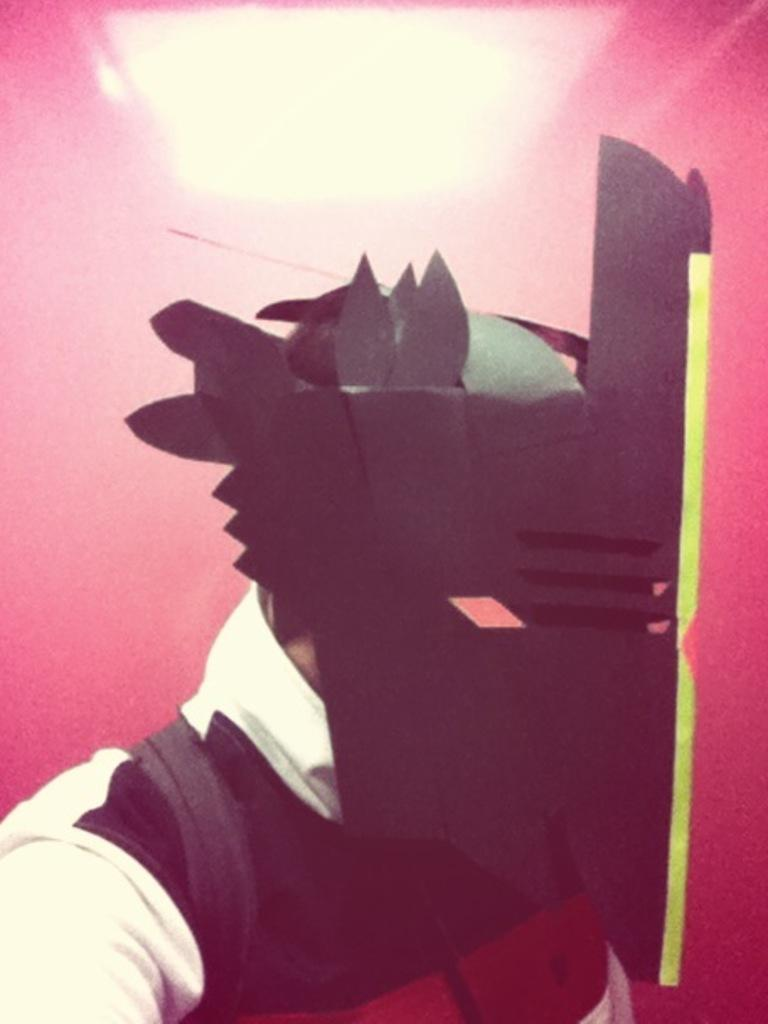Who or what is the main subject of the image? There is a person in the image. What is the person wearing on their face? The person is wearing a mask. What color is the background of the image? The background of the image is pink in color. What type of kite is the person holding in the image? There is no kite present in the image; the person is wearing a mask. What color is the dress the person is wearing in the image? There is no dress present in the image; the person is wearing a mask. 